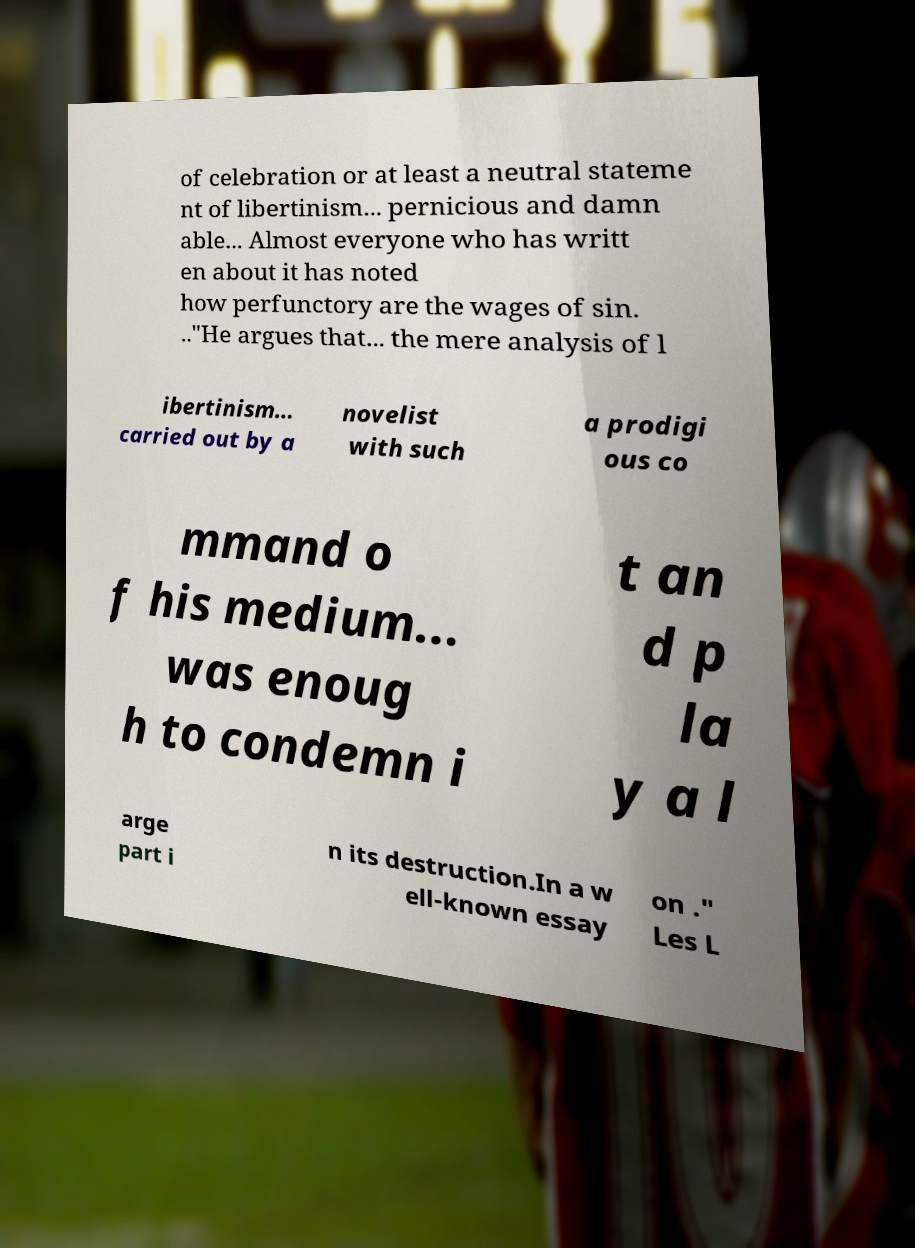Could you assist in decoding the text presented in this image and type it out clearly? of celebration or at least a neutral stateme nt of libertinism... pernicious and damn able... Almost everyone who has writt en about it has noted how perfunctory are the wages of sin. .."He argues that... the mere analysis of l ibertinism… carried out by a novelist with such a prodigi ous co mmand o f his medium... was enoug h to condemn i t an d p la y a l arge part i n its destruction.In a w ell-known essay on ." Les L 